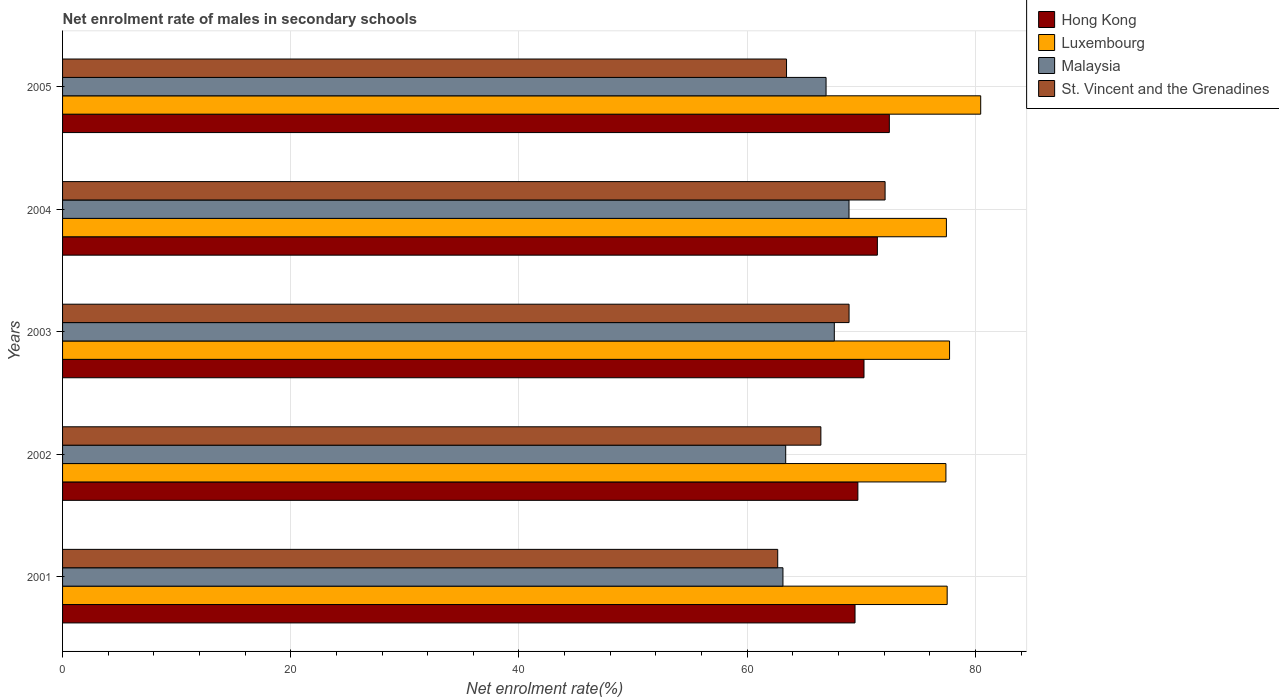Are the number of bars per tick equal to the number of legend labels?
Keep it short and to the point. Yes. How many bars are there on the 2nd tick from the top?
Your answer should be compact. 4. How many bars are there on the 5th tick from the bottom?
Your answer should be very brief. 4. What is the net enrolment rate of males in secondary schools in Hong Kong in 2003?
Ensure brevity in your answer.  70.24. Across all years, what is the maximum net enrolment rate of males in secondary schools in Luxembourg?
Your response must be concise. 80.46. Across all years, what is the minimum net enrolment rate of males in secondary schools in Luxembourg?
Your answer should be compact. 77.42. In which year was the net enrolment rate of males in secondary schools in St. Vincent and the Grenadines maximum?
Offer a terse response. 2004. What is the total net enrolment rate of males in secondary schools in Luxembourg in the graph?
Provide a short and direct response. 390.6. What is the difference between the net enrolment rate of males in secondary schools in Malaysia in 2004 and that in 2005?
Make the answer very short. 2.01. What is the difference between the net enrolment rate of males in secondary schools in Malaysia in 2005 and the net enrolment rate of males in secondary schools in Luxembourg in 2002?
Provide a short and direct response. -10.5. What is the average net enrolment rate of males in secondary schools in Malaysia per year?
Ensure brevity in your answer.  65.99. In the year 2004, what is the difference between the net enrolment rate of males in secondary schools in Hong Kong and net enrolment rate of males in secondary schools in Luxembourg?
Provide a short and direct response. -6.05. What is the ratio of the net enrolment rate of males in secondary schools in St. Vincent and the Grenadines in 2002 to that in 2005?
Offer a terse response. 1.05. What is the difference between the highest and the second highest net enrolment rate of males in secondary schools in St. Vincent and the Grenadines?
Ensure brevity in your answer.  3.16. What is the difference between the highest and the lowest net enrolment rate of males in secondary schools in St. Vincent and the Grenadines?
Make the answer very short. 9.41. In how many years, is the net enrolment rate of males in secondary schools in Malaysia greater than the average net enrolment rate of males in secondary schools in Malaysia taken over all years?
Ensure brevity in your answer.  3. What does the 1st bar from the top in 2001 represents?
Ensure brevity in your answer.  St. Vincent and the Grenadines. What does the 1st bar from the bottom in 2002 represents?
Make the answer very short. Hong Kong. Is it the case that in every year, the sum of the net enrolment rate of males in secondary schools in Luxembourg and net enrolment rate of males in secondary schools in Malaysia is greater than the net enrolment rate of males in secondary schools in Hong Kong?
Your answer should be compact. Yes. What is the difference between two consecutive major ticks on the X-axis?
Provide a short and direct response. 20. Does the graph contain grids?
Your response must be concise. Yes. Where does the legend appear in the graph?
Your answer should be compact. Top right. How many legend labels are there?
Your response must be concise. 4. What is the title of the graph?
Your answer should be compact. Net enrolment rate of males in secondary schools. Does "Denmark" appear as one of the legend labels in the graph?
Your answer should be very brief. No. What is the label or title of the X-axis?
Keep it short and to the point. Net enrolment rate(%). What is the label or title of the Y-axis?
Provide a succinct answer. Years. What is the Net enrolment rate(%) of Hong Kong in 2001?
Provide a short and direct response. 69.45. What is the Net enrolment rate(%) of Luxembourg in 2001?
Provide a short and direct response. 77.53. What is the Net enrolment rate(%) in Malaysia in 2001?
Give a very brief answer. 63.13. What is the Net enrolment rate(%) of St. Vincent and the Grenadines in 2001?
Ensure brevity in your answer.  62.67. What is the Net enrolment rate(%) of Hong Kong in 2002?
Give a very brief answer. 69.7. What is the Net enrolment rate(%) in Luxembourg in 2002?
Make the answer very short. 77.42. What is the Net enrolment rate(%) of Malaysia in 2002?
Make the answer very short. 63.37. What is the Net enrolment rate(%) in St. Vincent and the Grenadines in 2002?
Offer a terse response. 66.46. What is the Net enrolment rate(%) of Hong Kong in 2003?
Your answer should be very brief. 70.24. What is the Net enrolment rate(%) in Luxembourg in 2003?
Provide a short and direct response. 77.73. What is the Net enrolment rate(%) in Malaysia in 2003?
Your answer should be compact. 67.63. What is the Net enrolment rate(%) in St. Vincent and the Grenadines in 2003?
Your answer should be very brief. 68.93. What is the Net enrolment rate(%) in Hong Kong in 2004?
Give a very brief answer. 71.41. What is the Net enrolment rate(%) of Luxembourg in 2004?
Your answer should be very brief. 77.46. What is the Net enrolment rate(%) of Malaysia in 2004?
Give a very brief answer. 68.92. What is the Net enrolment rate(%) in St. Vincent and the Grenadines in 2004?
Ensure brevity in your answer.  72.08. What is the Net enrolment rate(%) in Hong Kong in 2005?
Provide a short and direct response. 72.46. What is the Net enrolment rate(%) in Luxembourg in 2005?
Keep it short and to the point. 80.46. What is the Net enrolment rate(%) in Malaysia in 2005?
Your response must be concise. 66.91. What is the Net enrolment rate(%) of St. Vincent and the Grenadines in 2005?
Keep it short and to the point. 63.45. Across all years, what is the maximum Net enrolment rate(%) of Hong Kong?
Provide a short and direct response. 72.46. Across all years, what is the maximum Net enrolment rate(%) in Luxembourg?
Provide a short and direct response. 80.46. Across all years, what is the maximum Net enrolment rate(%) of Malaysia?
Provide a succinct answer. 68.92. Across all years, what is the maximum Net enrolment rate(%) of St. Vincent and the Grenadines?
Offer a terse response. 72.08. Across all years, what is the minimum Net enrolment rate(%) of Hong Kong?
Provide a succinct answer. 69.45. Across all years, what is the minimum Net enrolment rate(%) of Luxembourg?
Give a very brief answer. 77.42. Across all years, what is the minimum Net enrolment rate(%) of Malaysia?
Your response must be concise. 63.13. Across all years, what is the minimum Net enrolment rate(%) in St. Vincent and the Grenadines?
Make the answer very short. 62.67. What is the total Net enrolment rate(%) of Hong Kong in the graph?
Ensure brevity in your answer.  353.25. What is the total Net enrolment rate(%) in Luxembourg in the graph?
Your answer should be very brief. 390.6. What is the total Net enrolment rate(%) of Malaysia in the graph?
Make the answer very short. 329.97. What is the total Net enrolment rate(%) of St. Vincent and the Grenadines in the graph?
Ensure brevity in your answer.  333.59. What is the difference between the Net enrolment rate(%) in Luxembourg in 2001 and that in 2002?
Offer a terse response. 0.11. What is the difference between the Net enrolment rate(%) of Malaysia in 2001 and that in 2002?
Your answer should be compact. -0.24. What is the difference between the Net enrolment rate(%) of St. Vincent and the Grenadines in 2001 and that in 2002?
Make the answer very short. -3.78. What is the difference between the Net enrolment rate(%) in Hong Kong in 2001 and that in 2003?
Provide a succinct answer. -0.79. What is the difference between the Net enrolment rate(%) of Luxembourg in 2001 and that in 2003?
Offer a terse response. -0.21. What is the difference between the Net enrolment rate(%) of Malaysia in 2001 and that in 2003?
Provide a succinct answer. -4.5. What is the difference between the Net enrolment rate(%) in St. Vincent and the Grenadines in 2001 and that in 2003?
Your response must be concise. -6.25. What is the difference between the Net enrolment rate(%) in Hong Kong in 2001 and that in 2004?
Your answer should be very brief. -1.96. What is the difference between the Net enrolment rate(%) of Luxembourg in 2001 and that in 2004?
Make the answer very short. 0.07. What is the difference between the Net enrolment rate(%) of Malaysia in 2001 and that in 2004?
Ensure brevity in your answer.  -5.79. What is the difference between the Net enrolment rate(%) of St. Vincent and the Grenadines in 2001 and that in 2004?
Make the answer very short. -9.41. What is the difference between the Net enrolment rate(%) of Hong Kong in 2001 and that in 2005?
Offer a terse response. -3.01. What is the difference between the Net enrolment rate(%) in Luxembourg in 2001 and that in 2005?
Provide a succinct answer. -2.94. What is the difference between the Net enrolment rate(%) of Malaysia in 2001 and that in 2005?
Make the answer very short. -3.78. What is the difference between the Net enrolment rate(%) in St. Vincent and the Grenadines in 2001 and that in 2005?
Provide a succinct answer. -0.77. What is the difference between the Net enrolment rate(%) of Hong Kong in 2002 and that in 2003?
Offer a very short reply. -0.54. What is the difference between the Net enrolment rate(%) of Luxembourg in 2002 and that in 2003?
Keep it short and to the point. -0.32. What is the difference between the Net enrolment rate(%) of Malaysia in 2002 and that in 2003?
Ensure brevity in your answer.  -4.26. What is the difference between the Net enrolment rate(%) of St. Vincent and the Grenadines in 2002 and that in 2003?
Make the answer very short. -2.47. What is the difference between the Net enrolment rate(%) of Hong Kong in 2002 and that in 2004?
Offer a very short reply. -1.71. What is the difference between the Net enrolment rate(%) in Luxembourg in 2002 and that in 2004?
Make the answer very short. -0.04. What is the difference between the Net enrolment rate(%) in Malaysia in 2002 and that in 2004?
Your answer should be compact. -5.55. What is the difference between the Net enrolment rate(%) in St. Vincent and the Grenadines in 2002 and that in 2004?
Offer a very short reply. -5.63. What is the difference between the Net enrolment rate(%) of Hong Kong in 2002 and that in 2005?
Keep it short and to the point. -2.76. What is the difference between the Net enrolment rate(%) of Luxembourg in 2002 and that in 2005?
Give a very brief answer. -3.05. What is the difference between the Net enrolment rate(%) in Malaysia in 2002 and that in 2005?
Give a very brief answer. -3.54. What is the difference between the Net enrolment rate(%) in St. Vincent and the Grenadines in 2002 and that in 2005?
Offer a terse response. 3.01. What is the difference between the Net enrolment rate(%) in Hong Kong in 2003 and that in 2004?
Ensure brevity in your answer.  -1.17. What is the difference between the Net enrolment rate(%) of Luxembourg in 2003 and that in 2004?
Offer a terse response. 0.28. What is the difference between the Net enrolment rate(%) of Malaysia in 2003 and that in 2004?
Provide a succinct answer. -1.29. What is the difference between the Net enrolment rate(%) of St. Vincent and the Grenadines in 2003 and that in 2004?
Provide a succinct answer. -3.16. What is the difference between the Net enrolment rate(%) of Hong Kong in 2003 and that in 2005?
Give a very brief answer. -2.22. What is the difference between the Net enrolment rate(%) of Luxembourg in 2003 and that in 2005?
Provide a succinct answer. -2.73. What is the difference between the Net enrolment rate(%) of Malaysia in 2003 and that in 2005?
Give a very brief answer. 0.72. What is the difference between the Net enrolment rate(%) in St. Vincent and the Grenadines in 2003 and that in 2005?
Make the answer very short. 5.48. What is the difference between the Net enrolment rate(%) in Hong Kong in 2004 and that in 2005?
Make the answer very short. -1.05. What is the difference between the Net enrolment rate(%) of Luxembourg in 2004 and that in 2005?
Offer a terse response. -3.01. What is the difference between the Net enrolment rate(%) of Malaysia in 2004 and that in 2005?
Your answer should be compact. 2.01. What is the difference between the Net enrolment rate(%) of St. Vincent and the Grenadines in 2004 and that in 2005?
Keep it short and to the point. 8.64. What is the difference between the Net enrolment rate(%) in Hong Kong in 2001 and the Net enrolment rate(%) in Luxembourg in 2002?
Your response must be concise. -7.97. What is the difference between the Net enrolment rate(%) in Hong Kong in 2001 and the Net enrolment rate(%) in Malaysia in 2002?
Offer a very short reply. 6.08. What is the difference between the Net enrolment rate(%) in Hong Kong in 2001 and the Net enrolment rate(%) in St. Vincent and the Grenadines in 2002?
Your answer should be very brief. 2.99. What is the difference between the Net enrolment rate(%) of Luxembourg in 2001 and the Net enrolment rate(%) of Malaysia in 2002?
Your response must be concise. 14.15. What is the difference between the Net enrolment rate(%) in Luxembourg in 2001 and the Net enrolment rate(%) in St. Vincent and the Grenadines in 2002?
Provide a short and direct response. 11.07. What is the difference between the Net enrolment rate(%) of Malaysia in 2001 and the Net enrolment rate(%) of St. Vincent and the Grenadines in 2002?
Provide a succinct answer. -3.32. What is the difference between the Net enrolment rate(%) of Hong Kong in 2001 and the Net enrolment rate(%) of Luxembourg in 2003?
Provide a succinct answer. -8.28. What is the difference between the Net enrolment rate(%) of Hong Kong in 2001 and the Net enrolment rate(%) of Malaysia in 2003?
Give a very brief answer. 1.82. What is the difference between the Net enrolment rate(%) of Hong Kong in 2001 and the Net enrolment rate(%) of St. Vincent and the Grenadines in 2003?
Offer a terse response. 0.52. What is the difference between the Net enrolment rate(%) of Luxembourg in 2001 and the Net enrolment rate(%) of Malaysia in 2003?
Offer a terse response. 9.89. What is the difference between the Net enrolment rate(%) of Luxembourg in 2001 and the Net enrolment rate(%) of St. Vincent and the Grenadines in 2003?
Your response must be concise. 8.6. What is the difference between the Net enrolment rate(%) of Malaysia in 2001 and the Net enrolment rate(%) of St. Vincent and the Grenadines in 2003?
Give a very brief answer. -5.79. What is the difference between the Net enrolment rate(%) of Hong Kong in 2001 and the Net enrolment rate(%) of Luxembourg in 2004?
Keep it short and to the point. -8.01. What is the difference between the Net enrolment rate(%) of Hong Kong in 2001 and the Net enrolment rate(%) of Malaysia in 2004?
Provide a short and direct response. 0.53. What is the difference between the Net enrolment rate(%) in Hong Kong in 2001 and the Net enrolment rate(%) in St. Vincent and the Grenadines in 2004?
Offer a very short reply. -2.63. What is the difference between the Net enrolment rate(%) of Luxembourg in 2001 and the Net enrolment rate(%) of Malaysia in 2004?
Offer a terse response. 8.6. What is the difference between the Net enrolment rate(%) in Luxembourg in 2001 and the Net enrolment rate(%) in St. Vincent and the Grenadines in 2004?
Your answer should be compact. 5.44. What is the difference between the Net enrolment rate(%) of Malaysia in 2001 and the Net enrolment rate(%) of St. Vincent and the Grenadines in 2004?
Offer a terse response. -8.95. What is the difference between the Net enrolment rate(%) of Hong Kong in 2001 and the Net enrolment rate(%) of Luxembourg in 2005?
Offer a very short reply. -11.01. What is the difference between the Net enrolment rate(%) in Hong Kong in 2001 and the Net enrolment rate(%) in Malaysia in 2005?
Provide a succinct answer. 2.54. What is the difference between the Net enrolment rate(%) in Hong Kong in 2001 and the Net enrolment rate(%) in St. Vincent and the Grenadines in 2005?
Provide a short and direct response. 6. What is the difference between the Net enrolment rate(%) of Luxembourg in 2001 and the Net enrolment rate(%) of Malaysia in 2005?
Provide a short and direct response. 10.61. What is the difference between the Net enrolment rate(%) of Luxembourg in 2001 and the Net enrolment rate(%) of St. Vincent and the Grenadines in 2005?
Make the answer very short. 14.08. What is the difference between the Net enrolment rate(%) in Malaysia in 2001 and the Net enrolment rate(%) in St. Vincent and the Grenadines in 2005?
Offer a very short reply. -0.31. What is the difference between the Net enrolment rate(%) of Hong Kong in 2002 and the Net enrolment rate(%) of Luxembourg in 2003?
Provide a succinct answer. -8.03. What is the difference between the Net enrolment rate(%) of Hong Kong in 2002 and the Net enrolment rate(%) of Malaysia in 2003?
Keep it short and to the point. 2.07. What is the difference between the Net enrolment rate(%) in Hong Kong in 2002 and the Net enrolment rate(%) in St. Vincent and the Grenadines in 2003?
Keep it short and to the point. 0.77. What is the difference between the Net enrolment rate(%) in Luxembourg in 2002 and the Net enrolment rate(%) in Malaysia in 2003?
Make the answer very short. 9.78. What is the difference between the Net enrolment rate(%) in Luxembourg in 2002 and the Net enrolment rate(%) in St. Vincent and the Grenadines in 2003?
Ensure brevity in your answer.  8.49. What is the difference between the Net enrolment rate(%) in Malaysia in 2002 and the Net enrolment rate(%) in St. Vincent and the Grenadines in 2003?
Your answer should be very brief. -5.55. What is the difference between the Net enrolment rate(%) in Hong Kong in 2002 and the Net enrolment rate(%) in Luxembourg in 2004?
Ensure brevity in your answer.  -7.76. What is the difference between the Net enrolment rate(%) of Hong Kong in 2002 and the Net enrolment rate(%) of Malaysia in 2004?
Your answer should be compact. 0.78. What is the difference between the Net enrolment rate(%) of Hong Kong in 2002 and the Net enrolment rate(%) of St. Vincent and the Grenadines in 2004?
Your answer should be very brief. -2.38. What is the difference between the Net enrolment rate(%) of Luxembourg in 2002 and the Net enrolment rate(%) of Malaysia in 2004?
Ensure brevity in your answer.  8.49. What is the difference between the Net enrolment rate(%) of Luxembourg in 2002 and the Net enrolment rate(%) of St. Vincent and the Grenadines in 2004?
Ensure brevity in your answer.  5.33. What is the difference between the Net enrolment rate(%) in Malaysia in 2002 and the Net enrolment rate(%) in St. Vincent and the Grenadines in 2004?
Provide a short and direct response. -8.71. What is the difference between the Net enrolment rate(%) in Hong Kong in 2002 and the Net enrolment rate(%) in Luxembourg in 2005?
Provide a short and direct response. -10.76. What is the difference between the Net enrolment rate(%) of Hong Kong in 2002 and the Net enrolment rate(%) of Malaysia in 2005?
Provide a succinct answer. 2.79. What is the difference between the Net enrolment rate(%) in Hong Kong in 2002 and the Net enrolment rate(%) in St. Vincent and the Grenadines in 2005?
Offer a terse response. 6.25. What is the difference between the Net enrolment rate(%) in Luxembourg in 2002 and the Net enrolment rate(%) in Malaysia in 2005?
Ensure brevity in your answer.  10.5. What is the difference between the Net enrolment rate(%) of Luxembourg in 2002 and the Net enrolment rate(%) of St. Vincent and the Grenadines in 2005?
Provide a succinct answer. 13.97. What is the difference between the Net enrolment rate(%) in Malaysia in 2002 and the Net enrolment rate(%) in St. Vincent and the Grenadines in 2005?
Your response must be concise. -0.07. What is the difference between the Net enrolment rate(%) of Hong Kong in 2003 and the Net enrolment rate(%) of Luxembourg in 2004?
Offer a terse response. -7.22. What is the difference between the Net enrolment rate(%) of Hong Kong in 2003 and the Net enrolment rate(%) of Malaysia in 2004?
Give a very brief answer. 1.31. What is the difference between the Net enrolment rate(%) in Hong Kong in 2003 and the Net enrolment rate(%) in St. Vincent and the Grenadines in 2004?
Your response must be concise. -1.85. What is the difference between the Net enrolment rate(%) of Luxembourg in 2003 and the Net enrolment rate(%) of Malaysia in 2004?
Your response must be concise. 8.81. What is the difference between the Net enrolment rate(%) of Luxembourg in 2003 and the Net enrolment rate(%) of St. Vincent and the Grenadines in 2004?
Keep it short and to the point. 5.65. What is the difference between the Net enrolment rate(%) in Malaysia in 2003 and the Net enrolment rate(%) in St. Vincent and the Grenadines in 2004?
Keep it short and to the point. -4.45. What is the difference between the Net enrolment rate(%) of Hong Kong in 2003 and the Net enrolment rate(%) of Luxembourg in 2005?
Give a very brief answer. -10.23. What is the difference between the Net enrolment rate(%) of Hong Kong in 2003 and the Net enrolment rate(%) of Malaysia in 2005?
Offer a very short reply. 3.32. What is the difference between the Net enrolment rate(%) in Hong Kong in 2003 and the Net enrolment rate(%) in St. Vincent and the Grenadines in 2005?
Provide a succinct answer. 6.79. What is the difference between the Net enrolment rate(%) in Luxembourg in 2003 and the Net enrolment rate(%) in Malaysia in 2005?
Make the answer very short. 10.82. What is the difference between the Net enrolment rate(%) of Luxembourg in 2003 and the Net enrolment rate(%) of St. Vincent and the Grenadines in 2005?
Make the answer very short. 14.29. What is the difference between the Net enrolment rate(%) in Malaysia in 2003 and the Net enrolment rate(%) in St. Vincent and the Grenadines in 2005?
Keep it short and to the point. 4.19. What is the difference between the Net enrolment rate(%) of Hong Kong in 2004 and the Net enrolment rate(%) of Luxembourg in 2005?
Give a very brief answer. -9.06. What is the difference between the Net enrolment rate(%) of Hong Kong in 2004 and the Net enrolment rate(%) of Malaysia in 2005?
Your answer should be very brief. 4.5. What is the difference between the Net enrolment rate(%) in Hong Kong in 2004 and the Net enrolment rate(%) in St. Vincent and the Grenadines in 2005?
Ensure brevity in your answer.  7.96. What is the difference between the Net enrolment rate(%) of Luxembourg in 2004 and the Net enrolment rate(%) of Malaysia in 2005?
Give a very brief answer. 10.55. What is the difference between the Net enrolment rate(%) of Luxembourg in 2004 and the Net enrolment rate(%) of St. Vincent and the Grenadines in 2005?
Your answer should be very brief. 14.01. What is the difference between the Net enrolment rate(%) of Malaysia in 2004 and the Net enrolment rate(%) of St. Vincent and the Grenadines in 2005?
Provide a succinct answer. 5.48. What is the average Net enrolment rate(%) in Hong Kong per year?
Your answer should be very brief. 70.65. What is the average Net enrolment rate(%) of Luxembourg per year?
Offer a very short reply. 78.12. What is the average Net enrolment rate(%) in Malaysia per year?
Offer a very short reply. 65.99. What is the average Net enrolment rate(%) in St. Vincent and the Grenadines per year?
Make the answer very short. 66.72. In the year 2001, what is the difference between the Net enrolment rate(%) in Hong Kong and Net enrolment rate(%) in Luxembourg?
Ensure brevity in your answer.  -8.08. In the year 2001, what is the difference between the Net enrolment rate(%) of Hong Kong and Net enrolment rate(%) of Malaysia?
Make the answer very short. 6.32. In the year 2001, what is the difference between the Net enrolment rate(%) in Hong Kong and Net enrolment rate(%) in St. Vincent and the Grenadines?
Your answer should be compact. 6.78. In the year 2001, what is the difference between the Net enrolment rate(%) in Luxembourg and Net enrolment rate(%) in Malaysia?
Offer a terse response. 14.39. In the year 2001, what is the difference between the Net enrolment rate(%) of Luxembourg and Net enrolment rate(%) of St. Vincent and the Grenadines?
Offer a terse response. 14.85. In the year 2001, what is the difference between the Net enrolment rate(%) in Malaysia and Net enrolment rate(%) in St. Vincent and the Grenadines?
Offer a very short reply. 0.46. In the year 2002, what is the difference between the Net enrolment rate(%) in Hong Kong and Net enrolment rate(%) in Luxembourg?
Offer a very short reply. -7.72. In the year 2002, what is the difference between the Net enrolment rate(%) of Hong Kong and Net enrolment rate(%) of Malaysia?
Offer a very short reply. 6.33. In the year 2002, what is the difference between the Net enrolment rate(%) of Hong Kong and Net enrolment rate(%) of St. Vincent and the Grenadines?
Your response must be concise. 3.24. In the year 2002, what is the difference between the Net enrolment rate(%) of Luxembourg and Net enrolment rate(%) of Malaysia?
Your response must be concise. 14.04. In the year 2002, what is the difference between the Net enrolment rate(%) in Luxembourg and Net enrolment rate(%) in St. Vincent and the Grenadines?
Ensure brevity in your answer.  10.96. In the year 2002, what is the difference between the Net enrolment rate(%) in Malaysia and Net enrolment rate(%) in St. Vincent and the Grenadines?
Provide a succinct answer. -3.08. In the year 2003, what is the difference between the Net enrolment rate(%) in Hong Kong and Net enrolment rate(%) in Luxembourg?
Give a very brief answer. -7.5. In the year 2003, what is the difference between the Net enrolment rate(%) of Hong Kong and Net enrolment rate(%) of Malaysia?
Provide a succinct answer. 2.6. In the year 2003, what is the difference between the Net enrolment rate(%) of Hong Kong and Net enrolment rate(%) of St. Vincent and the Grenadines?
Provide a succinct answer. 1.31. In the year 2003, what is the difference between the Net enrolment rate(%) in Luxembourg and Net enrolment rate(%) in Malaysia?
Make the answer very short. 10.1. In the year 2003, what is the difference between the Net enrolment rate(%) of Luxembourg and Net enrolment rate(%) of St. Vincent and the Grenadines?
Keep it short and to the point. 8.81. In the year 2003, what is the difference between the Net enrolment rate(%) in Malaysia and Net enrolment rate(%) in St. Vincent and the Grenadines?
Your answer should be very brief. -1.29. In the year 2004, what is the difference between the Net enrolment rate(%) in Hong Kong and Net enrolment rate(%) in Luxembourg?
Offer a terse response. -6.05. In the year 2004, what is the difference between the Net enrolment rate(%) of Hong Kong and Net enrolment rate(%) of Malaysia?
Ensure brevity in your answer.  2.49. In the year 2004, what is the difference between the Net enrolment rate(%) of Hong Kong and Net enrolment rate(%) of St. Vincent and the Grenadines?
Offer a very short reply. -0.68. In the year 2004, what is the difference between the Net enrolment rate(%) in Luxembourg and Net enrolment rate(%) in Malaysia?
Provide a succinct answer. 8.54. In the year 2004, what is the difference between the Net enrolment rate(%) of Luxembourg and Net enrolment rate(%) of St. Vincent and the Grenadines?
Keep it short and to the point. 5.37. In the year 2004, what is the difference between the Net enrolment rate(%) of Malaysia and Net enrolment rate(%) of St. Vincent and the Grenadines?
Make the answer very short. -3.16. In the year 2005, what is the difference between the Net enrolment rate(%) of Hong Kong and Net enrolment rate(%) of Luxembourg?
Keep it short and to the point. -8.01. In the year 2005, what is the difference between the Net enrolment rate(%) in Hong Kong and Net enrolment rate(%) in Malaysia?
Provide a short and direct response. 5.55. In the year 2005, what is the difference between the Net enrolment rate(%) in Hong Kong and Net enrolment rate(%) in St. Vincent and the Grenadines?
Ensure brevity in your answer.  9.01. In the year 2005, what is the difference between the Net enrolment rate(%) of Luxembourg and Net enrolment rate(%) of Malaysia?
Provide a succinct answer. 13.55. In the year 2005, what is the difference between the Net enrolment rate(%) in Luxembourg and Net enrolment rate(%) in St. Vincent and the Grenadines?
Offer a terse response. 17.02. In the year 2005, what is the difference between the Net enrolment rate(%) in Malaysia and Net enrolment rate(%) in St. Vincent and the Grenadines?
Give a very brief answer. 3.46. What is the ratio of the Net enrolment rate(%) of St. Vincent and the Grenadines in 2001 to that in 2002?
Ensure brevity in your answer.  0.94. What is the ratio of the Net enrolment rate(%) in Malaysia in 2001 to that in 2003?
Provide a succinct answer. 0.93. What is the ratio of the Net enrolment rate(%) in St. Vincent and the Grenadines in 2001 to that in 2003?
Ensure brevity in your answer.  0.91. What is the ratio of the Net enrolment rate(%) of Hong Kong in 2001 to that in 2004?
Make the answer very short. 0.97. What is the ratio of the Net enrolment rate(%) in Luxembourg in 2001 to that in 2004?
Provide a succinct answer. 1. What is the ratio of the Net enrolment rate(%) in Malaysia in 2001 to that in 2004?
Ensure brevity in your answer.  0.92. What is the ratio of the Net enrolment rate(%) of St. Vincent and the Grenadines in 2001 to that in 2004?
Your response must be concise. 0.87. What is the ratio of the Net enrolment rate(%) in Hong Kong in 2001 to that in 2005?
Your response must be concise. 0.96. What is the ratio of the Net enrolment rate(%) in Luxembourg in 2001 to that in 2005?
Provide a succinct answer. 0.96. What is the ratio of the Net enrolment rate(%) of Malaysia in 2001 to that in 2005?
Make the answer very short. 0.94. What is the ratio of the Net enrolment rate(%) of St. Vincent and the Grenadines in 2001 to that in 2005?
Your response must be concise. 0.99. What is the ratio of the Net enrolment rate(%) of Luxembourg in 2002 to that in 2003?
Your response must be concise. 1. What is the ratio of the Net enrolment rate(%) of Malaysia in 2002 to that in 2003?
Make the answer very short. 0.94. What is the ratio of the Net enrolment rate(%) in St. Vincent and the Grenadines in 2002 to that in 2003?
Keep it short and to the point. 0.96. What is the ratio of the Net enrolment rate(%) in Hong Kong in 2002 to that in 2004?
Offer a terse response. 0.98. What is the ratio of the Net enrolment rate(%) in Luxembourg in 2002 to that in 2004?
Offer a terse response. 1. What is the ratio of the Net enrolment rate(%) in Malaysia in 2002 to that in 2004?
Your answer should be very brief. 0.92. What is the ratio of the Net enrolment rate(%) in St. Vincent and the Grenadines in 2002 to that in 2004?
Your response must be concise. 0.92. What is the ratio of the Net enrolment rate(%) in Hong Kong in 2002 to that in 2005?
Provide a short and direct response. 0.96. What is the ratio of the Net enrolment rate(%) of Luxembourg in 2002 to that in 2005?
Keep it short and to the point. 0.96. What is the ratio of the Net enrolment rate(%) of Malaysia in 2002 to that in 2005?
Your answer should be compact. 0.95. What is the ratio of the Net enrolment rate(%) in St. Vincent and the Grenadines in 2002 to that in 2005?
Give a very brief answer. 1.05. What is the ratio of the Net enrolment rate(%) of Hong Kong in 2003 to that in 2004?
Provide a succinct answer. 0.98. What is the ratio of the Net enrolment rate(%) in Malaysia in 2003 to that in 2004?
Give a very brief answer. 0.98. What is the ratio of the Net enrolment rate(%) of St. Vincent and the Grenadines in 2003 to that in 2004?
Offer a very short reply. 0.96. What is the ratio of the Net enrolment rate(%) in Hong Kong in 2003 to that in 2005?
Ensure brevity in your answer.  0.97. What is the ratio of the Net enrolment rate(%) in Luxembourg in 2003 to that in 2005?
Your response must be concise. 0.97. What is the ratio of the Net enrolment rate(%) in Malaysia in 2003 to that in 2005?
Your response must be concise. 1.01. What is the ratio of the Net enrolment rate(%) of St. Vincent and the Grenadines in 2003 to that in 2005?
Your response must be concise. 1.09. What is the ratio of the Net enrolment rate(%) of Hong Kong in 2004 to that in 2005?
Provide a short and direct response. 0.99. What is the ratio of the Net enrolment rate(%) in Luxembourg in 2004 to that in 2005?
Your response must be concise. 0.96. What is the ratio of the Net enrolment rate(%) in Malaysia in 2004 to that in 2005?
Your answer should be very brief. 1.03. What is the ratio of the Net enrolment rate(%) in St. Vincent and the Grenadines in 2004 to that in 2005?
Ensure brevity in your answer.  1.14. What is the difference between the highest and the second highest Net enrolment rate(%) of Hong Kong?
Make the answer very short. 1.05. What is the difference between the highest and the second highest Net enrolment rate(%) in Luxembourg?
Offer a very short reply. 2.73. What is the difference between the highest and the second highest Net enrolment rate(%) of Malaysia?
Make the answer very short. 1.29. What is the difference between the highest and the second highest Net enrolment rate(%) of St. Vincent and the Grenadines?
Ensure brevity in your answer.  3.16. What is the difference between the highest and the lowest Net enrolment rate(%) in Hong Kong?
Make the answer very short. 3.01. What is the difference between the highest and the lowest Net enrolment rate(%) of Luxembourg?
Provide a succinct answer. 3.05. What is the difference between the highest and the lowest Net enrolment rate(%) in Malaysia?
Your answer should be very brief. 5.79. What is the difference between the highest and the lowest Net enrolment rate(%) in St. Vincent and the Grenadines?
Your response must be concise. 9.41. 